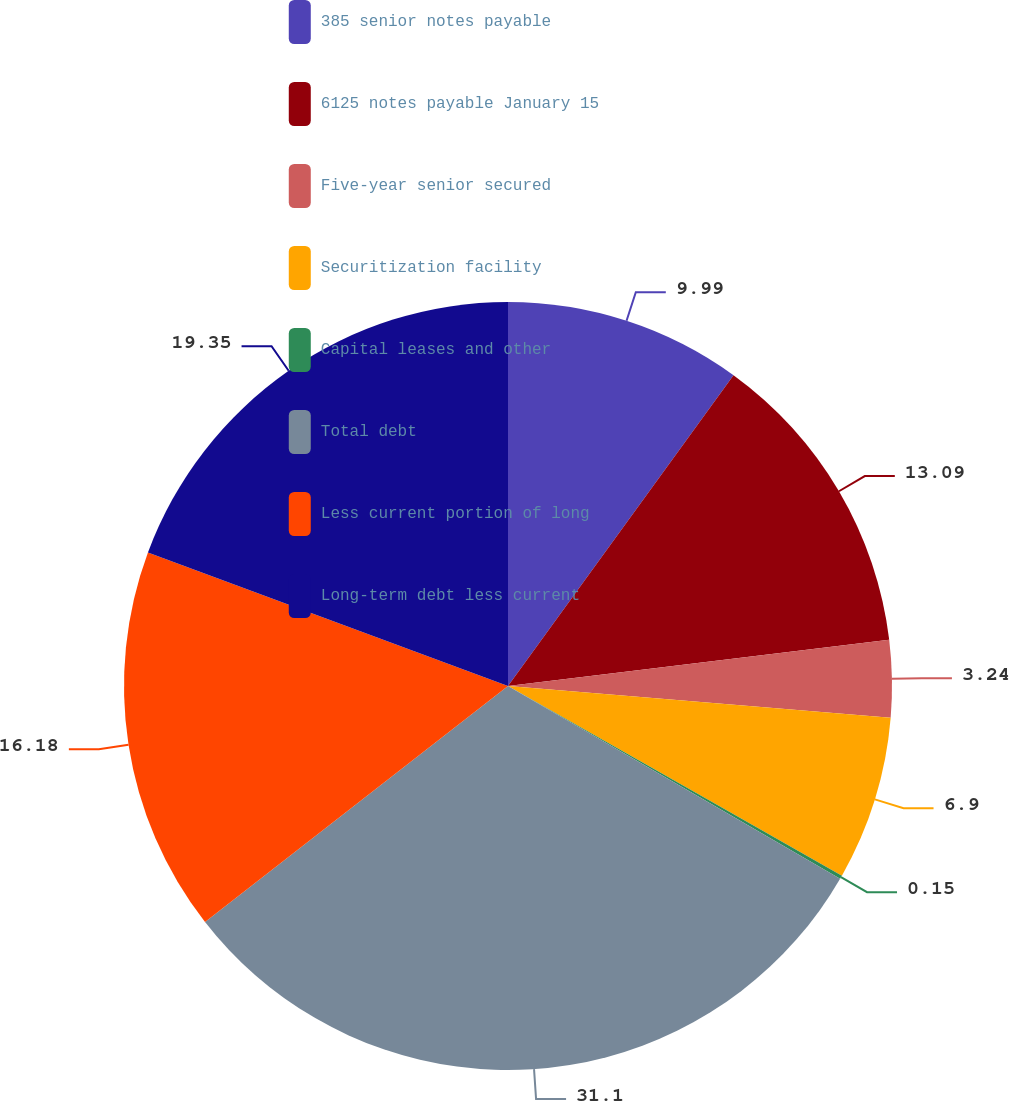Convert chart to OTSL. <chart><loc_0><loc_0><loc_500><loc_500><pie_chart><fcel>385 senior notes payable<fcel>6125 notes payable January 15<fcel>Five-year senior secured<fcel>Securitization facility<fcel>Capital leases and other<fcel>Total debt<fcel>Less current portion of long<fcel>Long-term debt less current<nl><fcel>9.99%<fcel>13.09%<fcel>3.24%<fcel>6.9%<fcel>0.15%<fcel>31.1%<fcel>16.18%<fcel>19.35%<nl></chart> 